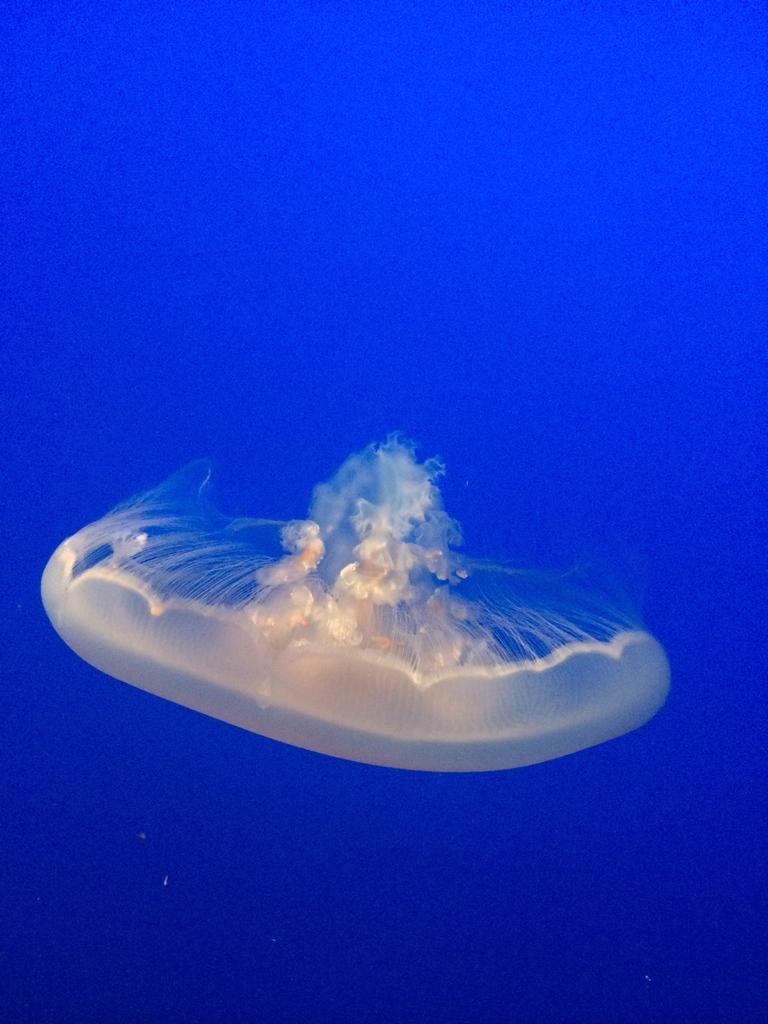Please provide a concise description of this image. In this picture we can see a jellyfish in the water. 